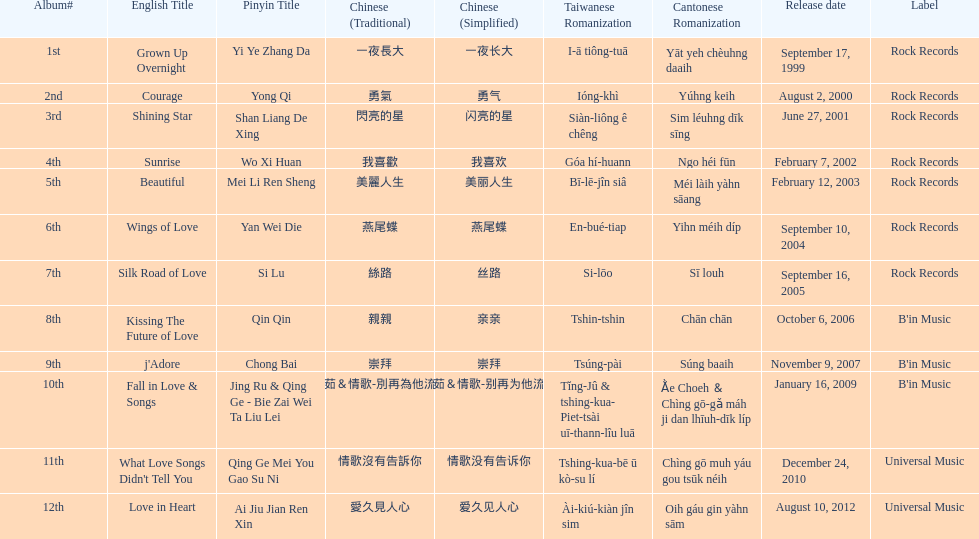Would you mind parsing the complete table? {'header': ['Album#', 'English Title', 'Pinyin Title', 'Chinese (Traditional)', 'Chinese (Simplified)', 'Taiwanese Romanization', 'Cantonese Romanization', 'Release date', 'Label'], 'rows': [['1st', 'Grown Up Overnight', 'Yi Ye Zhang Da', '一夜長大', '一夜长大', 'I-ā tiông-tuā', 'Yāt yeh chèuhng daaih', 'September 17, 1999', 'Rock Records'], ['2nd', 'Courage', 'Yong Qi', '勇氣', '勇气', 'Ióng-khì', 'Yúhng keih', 'August 2, 2000', 'Rock Records'], ['3rd', 'Shining Star', 'Shan Liang De Xing', '閃亮的星', '闪亮的星', 'Siàn-liông ê chêng', 'Sim léuhng dīk sīng', 'June 27, 2001', 'Rock Records'], ['4th', 'Sunrise', 'Wo Xi Huan', '我喜歡', '我喜欢', 'Góa hí-huann', 'Ngo héi fūn', 'February 7, 2002', 'Rock Records'], ['5th', 'Beautiful', 'Mei Li Ren Sheng', '美麗人生', '美丽人生', 'Bī-lē-jîn siâ', 'Méi làih yàhn sāang', 'February 12, 2003', 'Rock Records'], ['6th', 'Wings of Love', 'Yan Wei Die', '燕尾蝶', '燕尾蝶', 'En-bué-tiap', 'Yihn méih díp', 'September 10, 2004', 'Rock Records'], ['7th', 'Silk Road of Love', 'Si Lu', '絲路', '丝路', 'Si-lōo', 'Sī louh', 'September 16, 2005', 'Rock Records'], ['8th', 'Kissing The Future of Love', 'Qin Qin', '親親', '亲亲', 'Tshin-tshin', 'Chān chān', 'October 6, 2006', "B'in Music"], ['9th', "j'Adore", 'Chong Bai', '崇拜', '崇拜', 'Tsúng-pài', 'Súng baaih', 'November 9, 2007', "B'in Music"], ['10th', 'Fall in Love & Songs', 'Jing Ru & Qing Ge - Bie Zai Wei Ta Liu Lei', '靜茹＆情歌-別再為他流淚', '静茹＆情歌-别再为他流泪', 'Tĭng-Jû & tshing-kua- Piet-tsài uī-thann-lîu luā', 'Ằe Choeh ＆ Chìng gō-gǎ máh ji dan lhīuh-dīk líp', 'January 16, 2009', "B'in Music"], ['11th', "What Love Songs Didn't Tell You", 'Qing Ge Mei You Gao Su Ni', '情歌沒有告訴你', '情歌没有告诉你', 'Tshing-kua-bē ū kò-su lí', 'Chìng gō muh yáu gou tsūk néih', 'December 24, 2010', 'Universal Music'], ['12th', 'Love in Heart', 'Ai Jiu Jian Ren Xin', '愛久見人心', '爱久见人心', 'Ài-kiú-kiàn jîn sim', 'Oih gáu gin yàhn sām', 'August 10, 2012', 'Universal Music']]} Which was the only album to be released by b'in music in an even-numbered year? Kissing The Future of Love. 